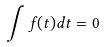<formula> <loc_0><loc_0><loc_500><loc_500>\int f ( t ) d t = 0</formula> 